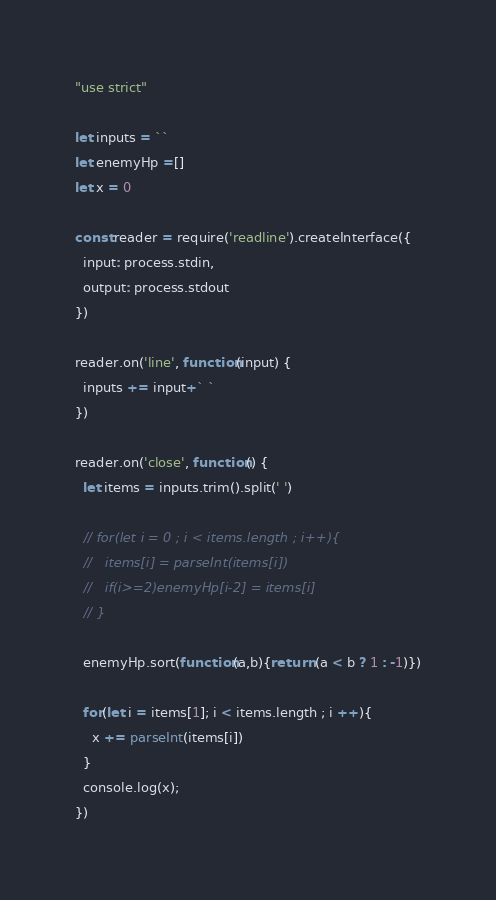Convert code to text. <code><loc_0><loc_0><loc_500><loc_500><_JavaScript_>"use strict"

let inputs = ``
let enemyHp =[]
let x = 0

const reader = require('readline').createInterface({
  input: process.stdin,
  output: process.stdout
})

reader.on('line', function(input) {
  inputs += input+` `
})

reader.on('close', function() {
  let items = inputs.trim().split(' ')
  
  // for(let i = 0 ; i < items.length ; i++){
  //   items[i] = parseInt(items[i])
  //   if(i>=2)enemyHp[i-2] = items[i]
  // }

  enemyHp.sort(function(a,b){return (a < b ? 1 : -1)})
  
  for(let i = items[1]; i < items.length ; i ++){
    x += parseInt(items[i])
  }
  console.log(x);
})</code> 